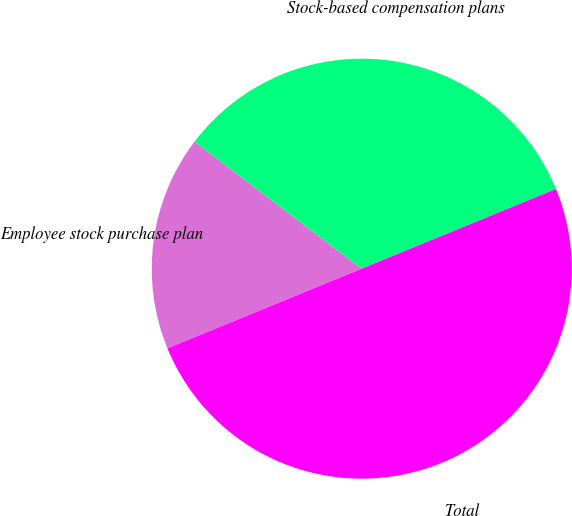Convert chart. <chart><loc_0><loc_0><loc_500><loc_500><pie_chart><fcel>Employee stock purchase plan<fcel>Stock-based compensation plans<fcel>Total<nl><fcel>16.54%<fcel>33.46%<fcel>50.0%<nl></chart> 